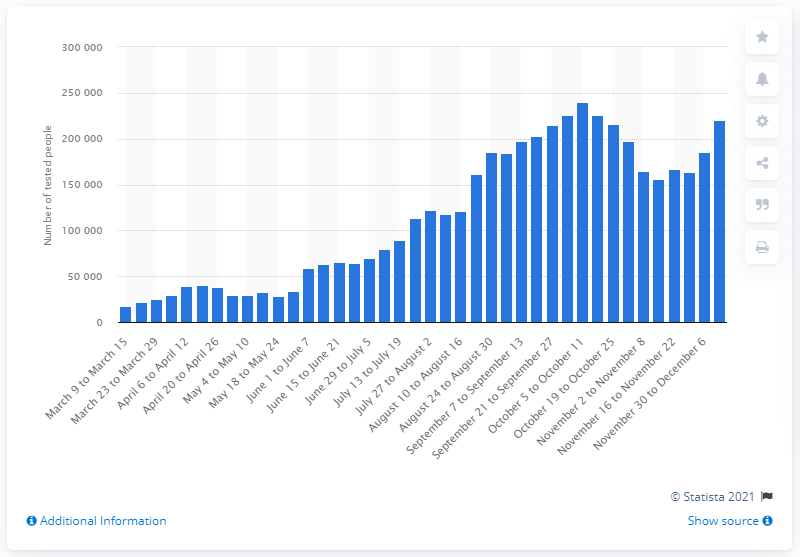Point out several critical features in this image. During the period of December 7th to 13th 2020, a total of 220,504 people were tested for COVID-19. 